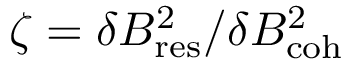<formula> <loc_0><loc_0><loc_500><loc_500>\zeta = \delta B _ { r e s } ^ { 2 } / \delta B _ { c o h } ^ { 2 }</formula> 